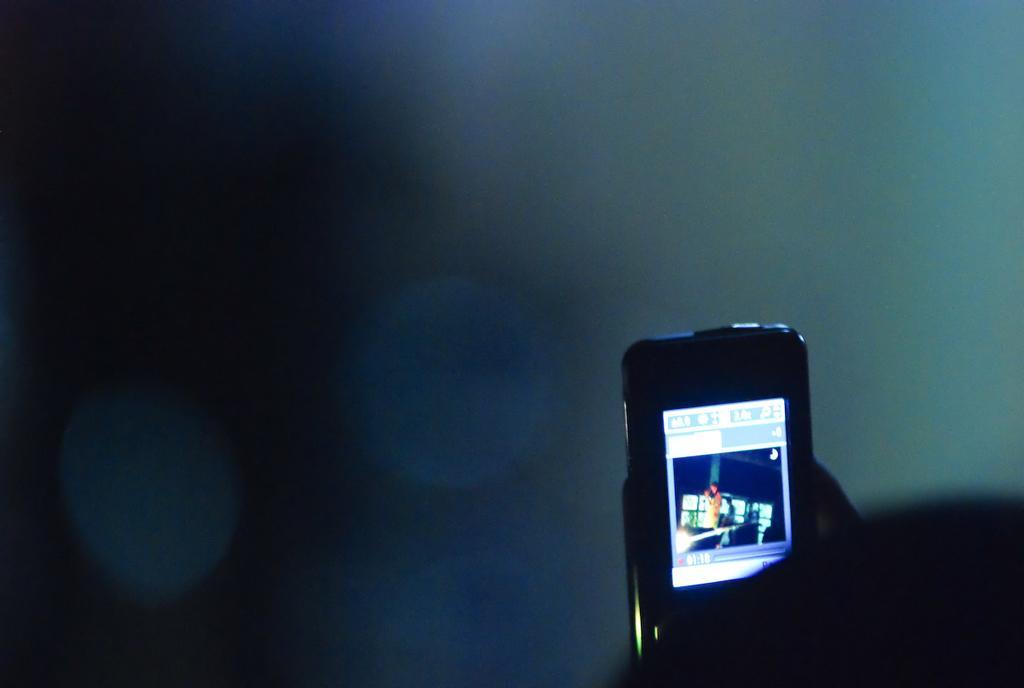How would you summarize this image in a sentence or two? In this picture we can see a mobile and in the background it is dark. 